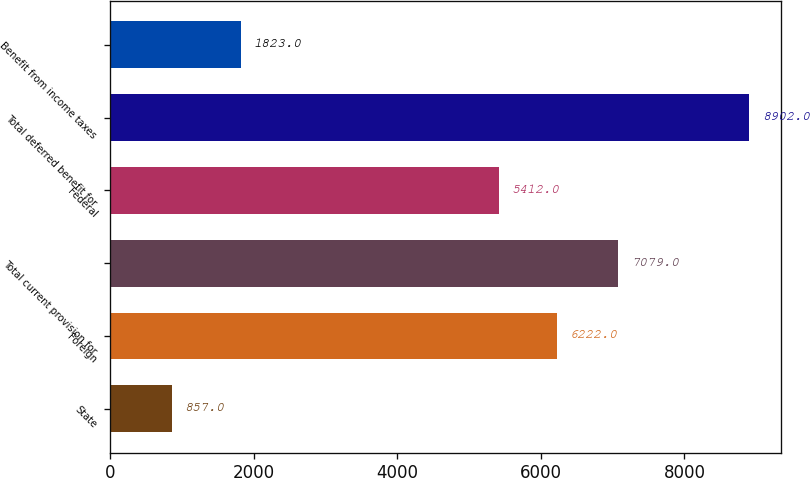Convert chart. <chart><loc_0><loc_0><loc_500><loc_500><bar_chart><fcel>State<fcel>Foreign<fcel>Total current provision for<fcel>Federal<fcel>Total deferred benefit for<fcel>Benefit from income taxes<nl><fcel>857<fcel>6222<fcel>7079<fcel>5412<fcel>8902<fcel>1823<nl></chart> 